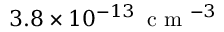<formula> <loc_0><loc_0><loc_500><loc_500>3 . 8 \times 1 0 ^ { - 1 3 } \, c m ^ { - 3 }</formula> 